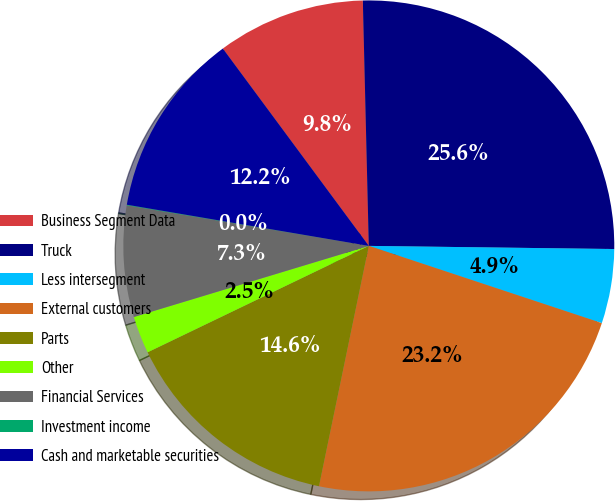Convert chart to OTSL. <chart><loc_0><loc_0><loc_500><loc_500><pie_chart><fcel>Business Segment Data<fcel>Truck<fcel>Less intersegment<fcel>External customers<fcel>Parts<fcel>Other<fcel>Financial Services<fcel>Investment income<fcel>Cash and marketable securities<nl><fcel>9.75%<fcel>25.59%<fcel>4.89%<fcel>23.16%<fcel>14.61%<fcel>2.46%<fcel>7.32%<fcel>0.04%<fcel>12.18%<nl></chart> 